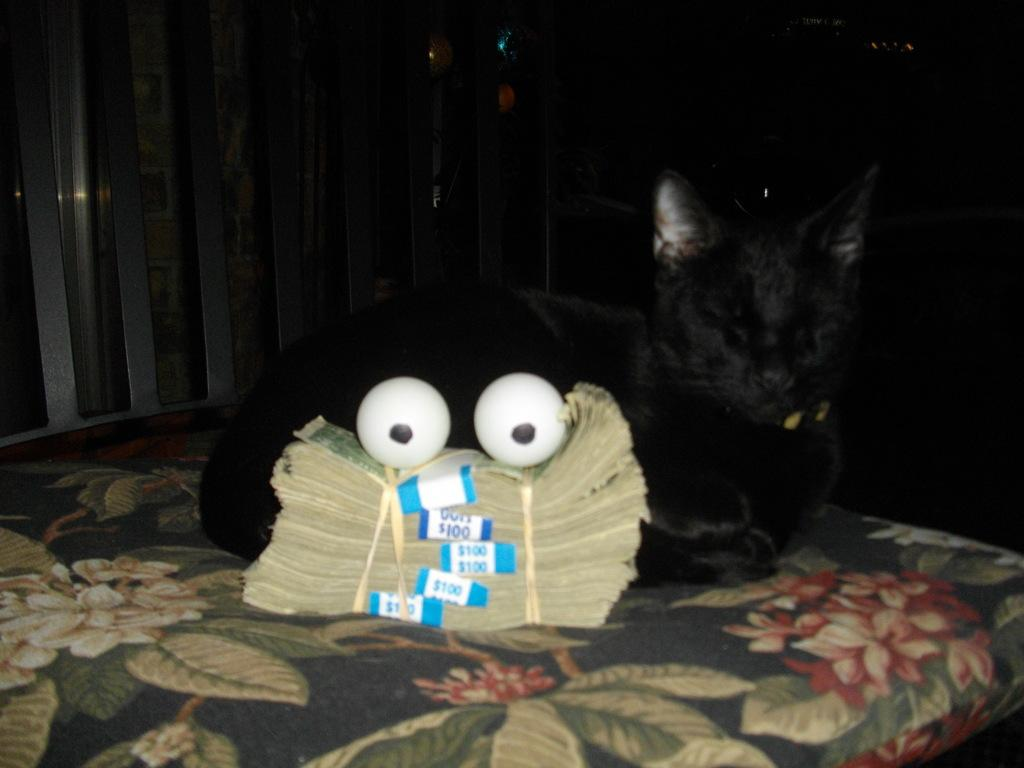What is located in the center of the picture? There are currency notes, eyeballs, and a cat on a bed in the center of the picture. Can you describe the objects in the background of the picture? There are balloons and an iron object in the background of the picture. What type of crown is the fowl wearing in the image? There is no crown or fowl present in the image. How does the idea manifest itself in the image? The image does not depict an idea; it shows currency notes, eyeballs, a cat on a bed, balloons, and an iron object. 